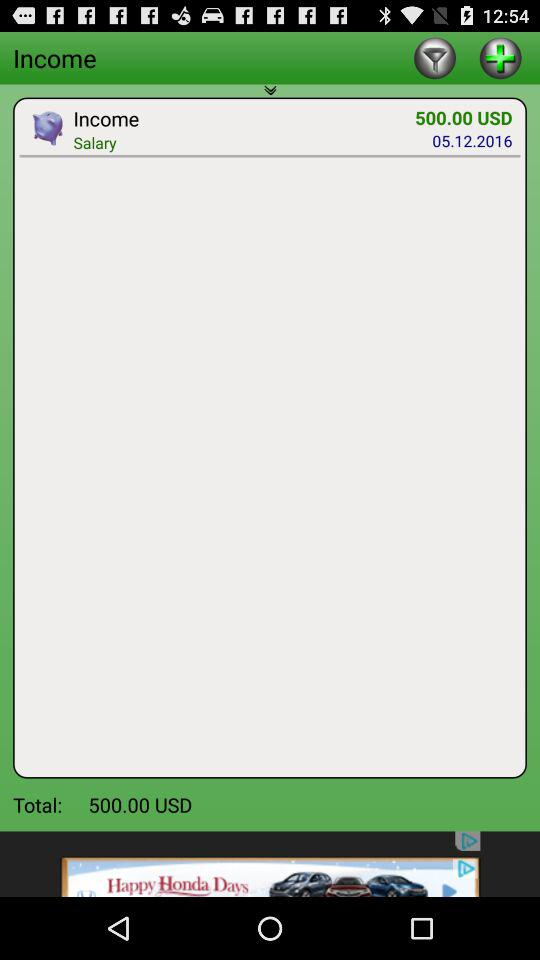What is the date of this transaction?
Answer the question using a single word or phrase. 05.12.2016 